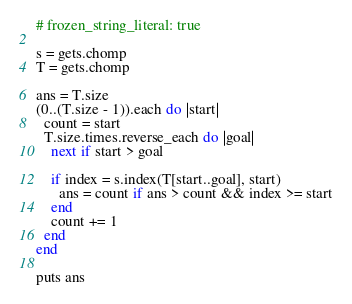<code> <loc_0><loc_0><loc_500><loc_500><_Ruby_># frozen_string_literal: true

s = gets.chomp
T = gets.chomp

ans = T.size
(0..(T.size - 1)).each do |start|
  count = start
  T.size.times.reverse_each do |goal|
    next if start > goal

    if index = s.index(T[start..goal], start)
      ans = count if ans > count && index >= start
    end
    count += 1
  end
end

puts ans
</code> 